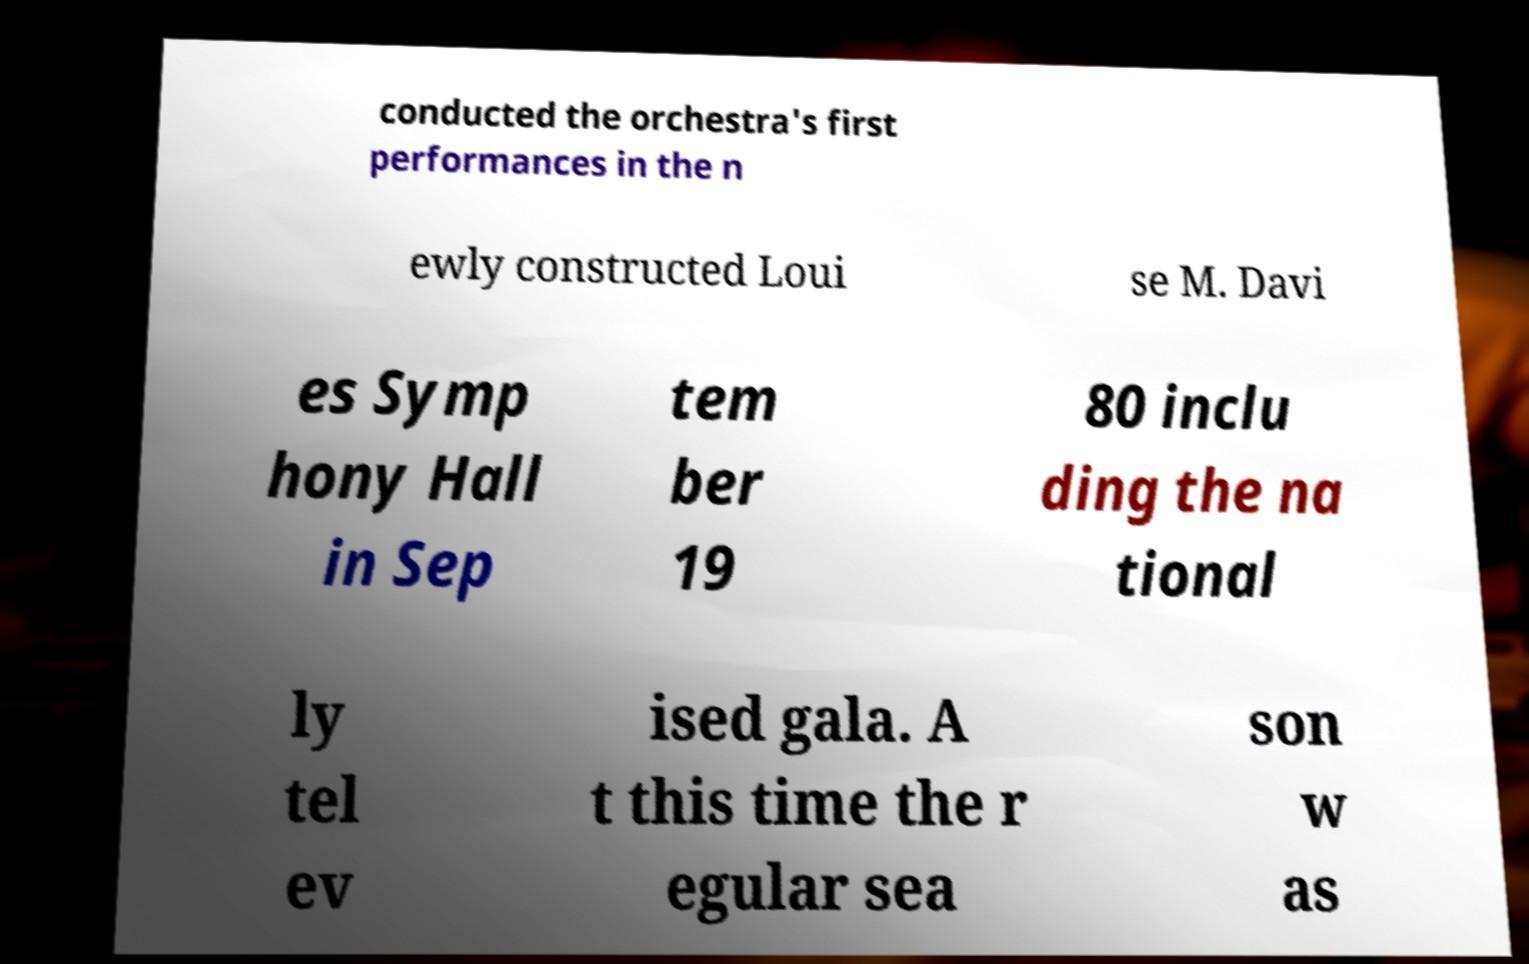I need the written content from this picture converted into text. Can you do that? conducted the orchestra's first performances in the n ewly constructed Loui se M. Davi es Symp hony Hall in Sep tem ber 19 80 inclu ding the na tional ly tel ev ised gala. A t this time the r egular sea son w as 